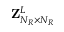<formula> <loc_0><loc_0><loc_500><loc_500>{ Z } _ { N _ { R } \times N _ { R } } ^ { L }</formula> 